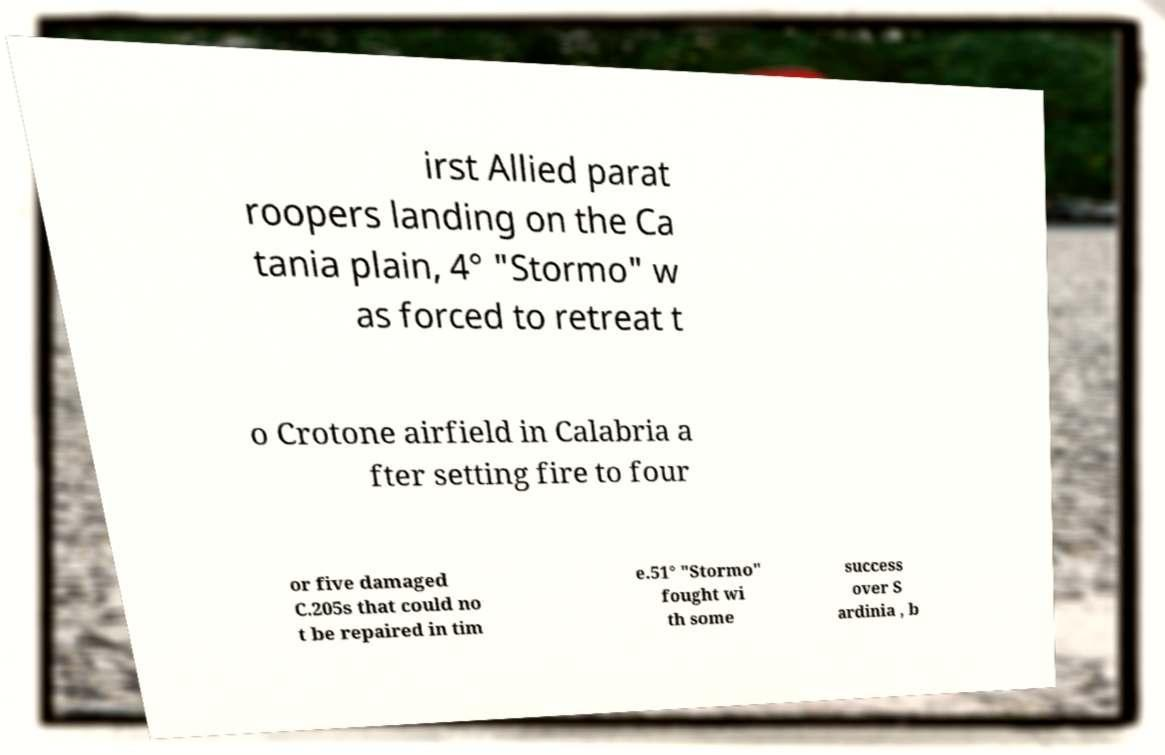I need the written content from this picture converted into text. Can you do that? irst Allied parat roopers landing on the Ca tania plain, 4° "Stormo" w as forced to retreat t o Crotone airfield in Calabria a fter setting fire to four or five damaged C.205s that could no t be repaired in tim e.51° "Stormo" fought wi th some success over S ardinia , b 